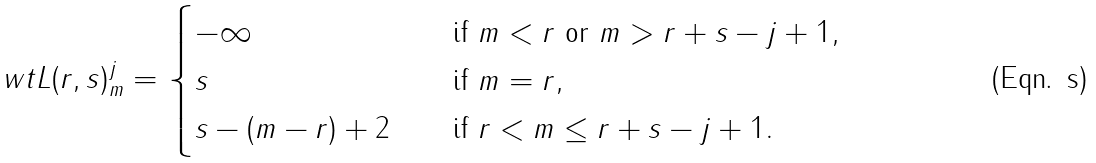Convert formula to latex. <formula><loc_0><loc_0><loc_500><loc_500>\ w t { L } ( r , s ) _ { m } ^ { j } = \begin{cases} - \infty \quad & \text {if } m < r \text { or } m > r + s - j + 1 , \\ s \quad & \text {if } m = r , \\ s - ( m - r ) + 2 \quad & \text {if } r < m \leq r + s - j + 1 . \end{cases}</formula> 